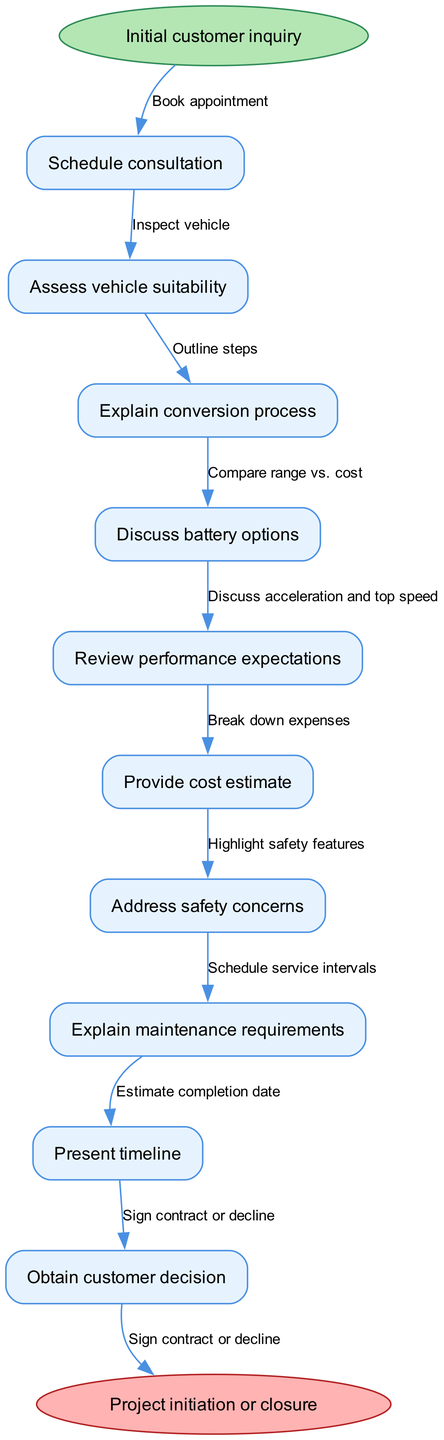What is the starting point of the consultation process? The starting point is clearly labeled as "Initial customer inquiry" in the diagram, indicating where the process begins.
Answer: Initial customer inquiry How many main process nodes are present in the diagram? The diagram lists a total of 10 main process nodes, each corresponding to specific steps in the customer consultation and education process.
Answer: 10 What is the final step in the process? The last node leads to "Project initiation or closure," signifying the outcome of the consultation process.
Answer: Project initiation or closure What connects the "Schedule consultation" node to the "Assess vehicle suitability" node? The edge labeled "Book appointment" connects these two nodes, depicting the direct relationship between scheduling and assessing.
Answer: Book appointment Which node explains maintenance requirements? "Explain maintenance requirements" is the specific node that deals with educating the customer about what maintenance will be necessary after the conversion.
Answer: Explain maintenance requirements What action follows the "Review performance expectations" node? After "Review performance expectations," the next action is "Provide cost estimate," indicating a progression from expectations to financial considerations.
Answer: Provide cost estimate What is the relationship between "Explain conversion process" and "Discuss battery options"? The edge "Outline steps" represents the relationship between "Explain conversion process" and "Discuss battery options," indicating sequential flow in the dialogue.
Answer: Outline steps What must happen after discussing battery options? The next step after discussing battery options is to "Review performance expectations," which outlines the importance of understanding the capabilities of different batteries.
Answer: Review performance expectations How does the customer provide their decision at the end of the pathway? The decision is indicated through the node "Obtain customer decision," which leads to either "Sign contract or decline."
Answer: Sign contract or decline 